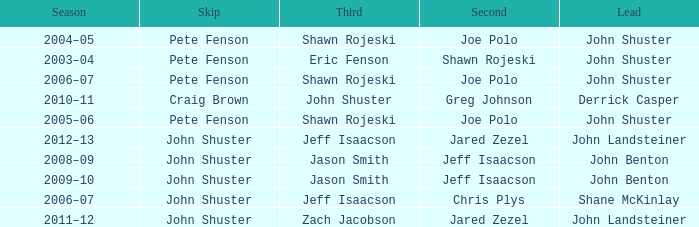Who was the lead with John Shuster as skip, Chris Plys in second, and Jeff Isaacson in third? Shane McKinlay. 